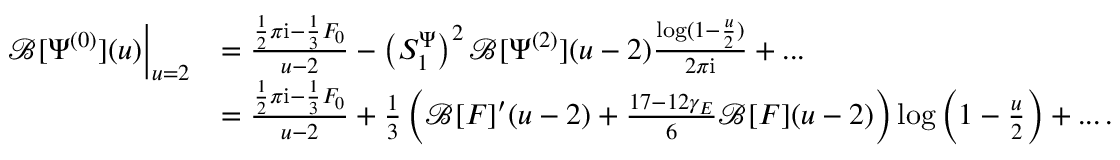<formula> <loc_0><loc_0><loc_500><loc_500>\begin{array} { r l } { \mathcal { B } [ \Psi ^ { ( 0 ) } ] ( u ) \Big | _ { u = 2 } } & { = \frac { \frac { 1 } { 2 } \pi i - \frac { 1 } { 3 } F _ { 0 } } { u - 2 } - \left ( S _ { 1 } ^ { \Psi } \right ) ^ { 2 } \mathcal { B } [ \Psi ^ { ( 2 ) } ] ( u - 2 ) \frac { \log ( 1 - \frac { u } { 2 } ) } { 2 \pi i } + \dots } \\ & { = \frac { \frac { 1 } { 2 } \pi i - \frac { 1 } { 3 } F _ { 0 } } { u - 2 } + \frac { 1 } { 3 } \left ( \mathcal { B } [ F ] ^ { \prime } ( u - 2 ) + \frac { 1 7 - 1 2 \gamma _ { E } } { 6 } \mathcal { B } [ F ] ( u - 2 ) \right ) \log \left ( 1 - \frac { u } { 2 } \right ) + \dots \, . } \end{array}</formula> 